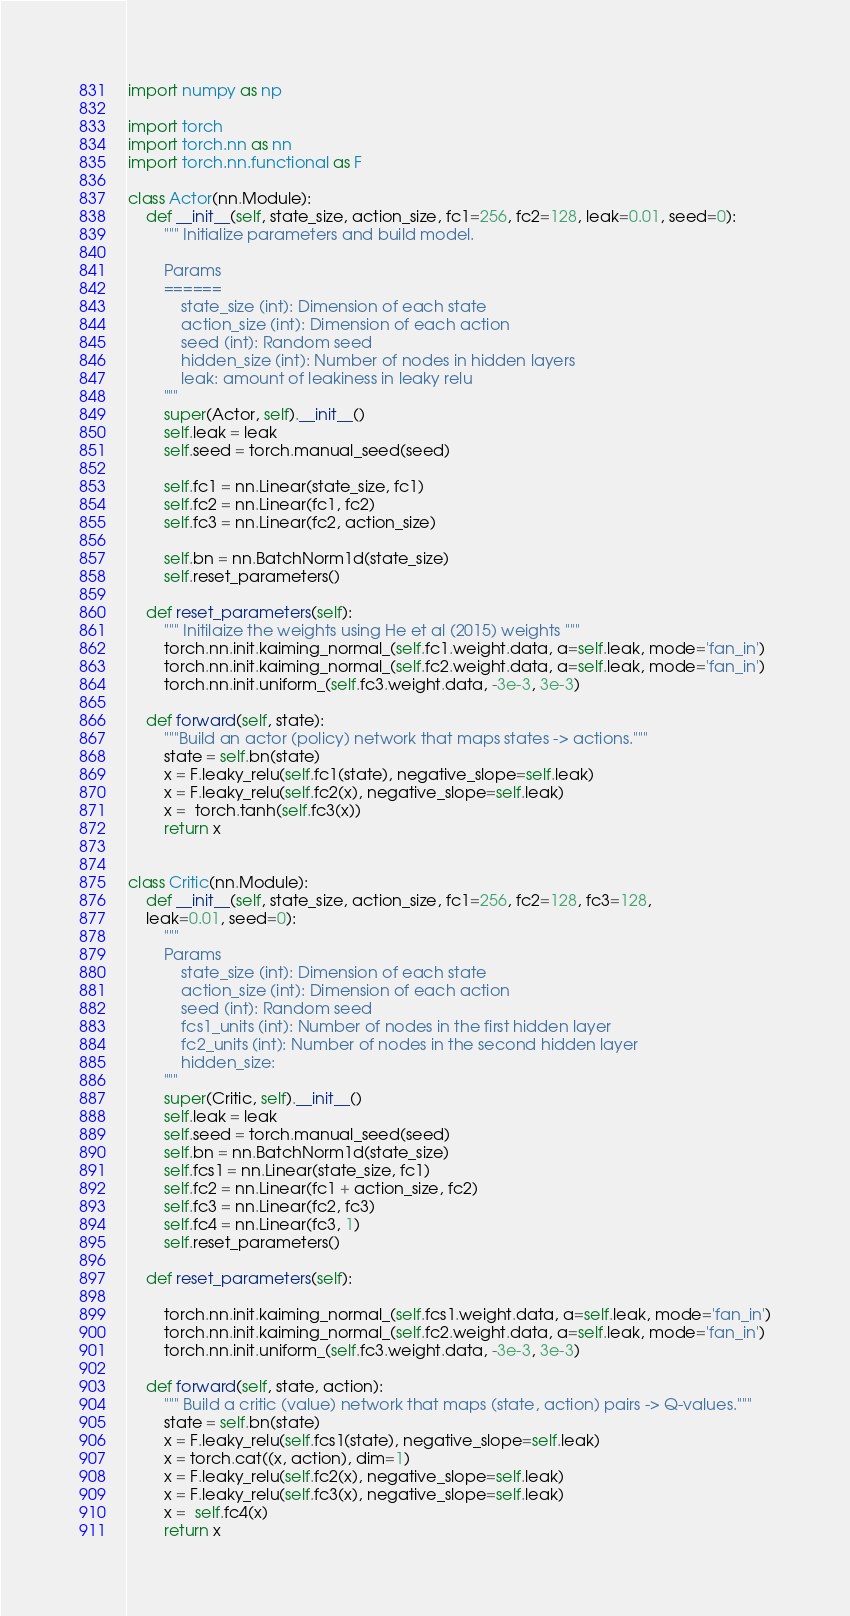<code> <loc_0><loc_0><loc_500><loc_500><_Python_>import numpy as np

import torch
import torch.nn as nn
import torch.nn.functional as F

class Actor(nn.Module):
    def __init__(self, state_size, action_size, fc1=256, fc2=128, leak=0.01, seed=0):
        """ Initialize parameters and build model.

        Params
        ======
            state_size (int): Dimension of each state
            action_size (int): Dimension of each action
            seed (int): Random seed
            hidden_size (int): Number of nodes in hidden layers
            leak: amount of leakiness in leaky relu
        """
        super(Actor, self).__init__()
        self.leak = leak
        self.seed = torch.manual_seed(seed)

        self.fc1 = nn.Linear(state_size, fc1)
        self.fc2 = nn.Linear(fc1, fc2)
        self.fc3 = nn.Linear(fc2, action_size)

        self.bn = nn.BatchNorm1d(state_size)
        self.reset_parameters()

    def reset_parameters(self):
        """ Initilaize the weights using He et al (2015) weights """
        torch.nn.init.kaiming_normal_(self.fc1.weight.data, a=self.leak, mode='fan_in')
        torch.nn.init.kaiming_normal_(self.fc2.weight.data, a=self.leak, mode='fan_in')
        torch.nn.init.uniform_(self.fc3.weight.data, -3e-3, 3e-3)

    def forward(self, state):
        """Build an actor (policy) network that maps states -> actions."""
        state = self.bn(state)
        x = F.leaky_relu(self.fc1(state), negative_slope=self.leak)
        x = F.leaky_relu(self.fc2(x), negative_slope=self.leak)
        x =  torch.tanh(self.fc3(x))
        return x


class Critic(nn.Module):
    def __init__(self, state_size, action_size, fc1=256, fc2=128, fc3=128,
    leak=0.01, seed=0):
        """
        Params
            state_size (int): Dimension of each state
            action_size (int): Dimension of each action
            seed (int): Random seed
            fcs1_units (int): Number of nodes in the first hidden layer
            fc2_units (int): Number of nodes in the second hidden layer
            hidden_size:
        """
        super(Critic, self).__init__()
        self.leak = leak
        self.seed = torch.manual_seed(seed)
        self.bn = nn.BatchNorm1d(state_size)
        self.fcs1 = nn.Linear(state_size, fc1)
        self.fc2 = nn.Linear(fc1 + action_size, fc2)
        self.fc3 = nn.Linear(fc2, fc3)
        self.fc4 = nn.Linear(fc3, 1)
        self.reset_parameters()

    def reset_parameters(self):
        
        torch.nn.init.kaiming_normal_(self.fcs1.weight.data, a=self.leak, mode='fan_in')
        torch.nn.init.kaiming_normal_(self.fc2.weight.data, a=self.leak, mode='fan_in')
        torch.nn.init.uniform_(self.fc3.weight.data, -3e-3, 3e-3)

    def forward(self, state, action):
        """ Build a critic (value) network that maps (state, action) pairs -> Q-values."""
        state = self.bn(state)
        x = F.leaky_relu(self.fcs1(state), negative_slope=self.leak)
        x = torch.cat((x, action), dim=1)
        x = F.leaky_relu(self.fc2(x), negative_slope=self.leak)
        x = F.leaky_relu(self.fc3(x), negative_slope=self.leak)
        x =  self.fc4(x)
        return x
</code> 